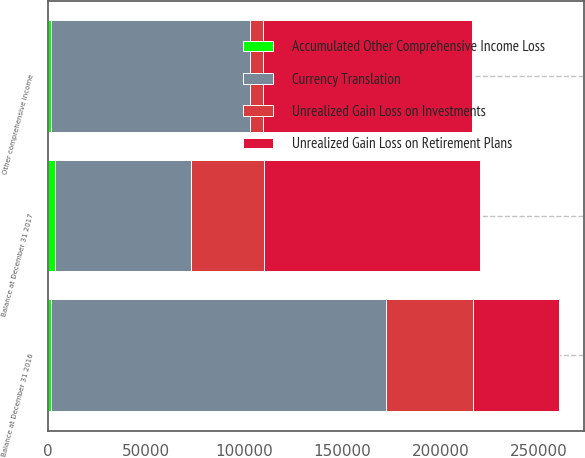Convert chart. <chart><loc_0><loc_0><loc_500><loc_500><stacked_bar_chart><ecel><fcel>Balance at December 31 2016<fcel>Other comprehensive income<fcel>Balance at December 31 2017<nl><fcel>Currency Translation<fcel>170566<fcel>101148<fcel>69418<nl><fcel>Unrealized Gain Loss on Investments<fcel>43894<fcel>6791<fcel>37103<nl><fcel>Accumulated Other Comprehensive Income Loss<fcel>1820<fcel>1726<fcel>3546<nl><fcel>Unrealized Gain Loss on Retirement Plans<fcel>43894<fcel>106213<fcel>110067<nl></chart> 